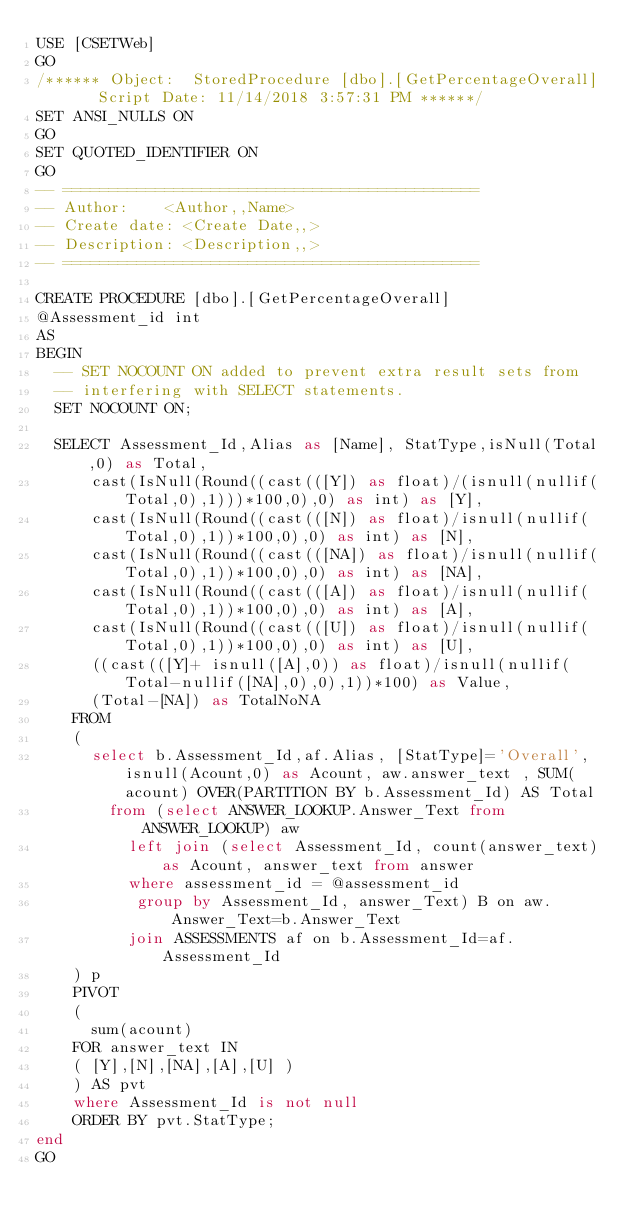<code> <loc_0><loc_0><loc_500><loc_500><_SQL_>USE [CSETWeb]
GO
/****** Object:  StoredProcedure [dbo].[GetPercentageOverall]    Script Date: 11/14/2018 3:57:31 PM ******/
SET ANSI_NULLS ON
GO
SET QUOTED_IDENTIFIER ON
GO
-- =============================================
-- Author:		<Author,,Name>
-- Create date: <Create Date,,>
-- Description:	<Description,,>
-- =============================================

CREATE PROCEDURE [dbo].[GetPercentageOverall]
@Assessment_id int 	
AS
BEGIN
	-- SET NOCOUNT ON added to prevent extra result sets from
	-- interfering with SELECT statements.
	SET NOCOUNT ON;

	SELECT Assessment_Id,Alias as [Name], StatType,isNull(Total,0) as Total, 
			cast(IsNull(Round((cast(([Y]) as float)/(isnull(nullif(Total,0),1)))*100,0),0) as int) as [Y],			
			cast(IsNull(Round((cast(([N]) as float)/isnull(nullif(Total,0),1))*100,0),0) as int) as [N],
			cast(IsNull(Round((cast(([NA]) as float)/isnull(nullif(Total,0),1))*100,0),0) as int) as [NA],
			cast(IsNull(Round((cast(([A]) as float)/isnull(nullif(Total,0),1))*100,0),0) as int) as [A],
			cast(IsNull(Round((cast(([U]) as float)/isnull(nullif(Total,0),1))*100,0),0) as int) as [U],			
			((cast(([Y]+ isnull([A],0)) as float)/isnull(nullif(Total-nullif([NA],0),0),1))*100) as Value, 			
			(Total-[NA]) as TotalNoNA 				
		FROM 
		(
			select b.Assessment_Id,af.Alias, [StatType]='Overall', isnull(Acount,0) as Acount, aw.answer_text , SUM(acount) OVER(PARTITION BY b.Assessment_Id) AS Total  
				from (select ANSWER_LOOKUP.Answer_Text from ANSWER_LOOKUP) aw 
					left join (select Assessment_Id, count(answer_text) as Acount, answer_text from answer
					where assessment_id = @assessment_id
					 group by Assessment_Id, answer_Text) B on aw.Answer_Text=b.Answer_Text 
					join ASSESSMENTS af on b.Assessment_Id=af.Assessment_Id			
		) p
		PIVOT
		(
			sum(acount) 
		FOR answer_text IN
		( [Y],[N],[NA],[A],[U] )
		) AS pvt
		where Assessment_Id is not null
		ORDER BY pvt.StatType;
end
GO
</code> 